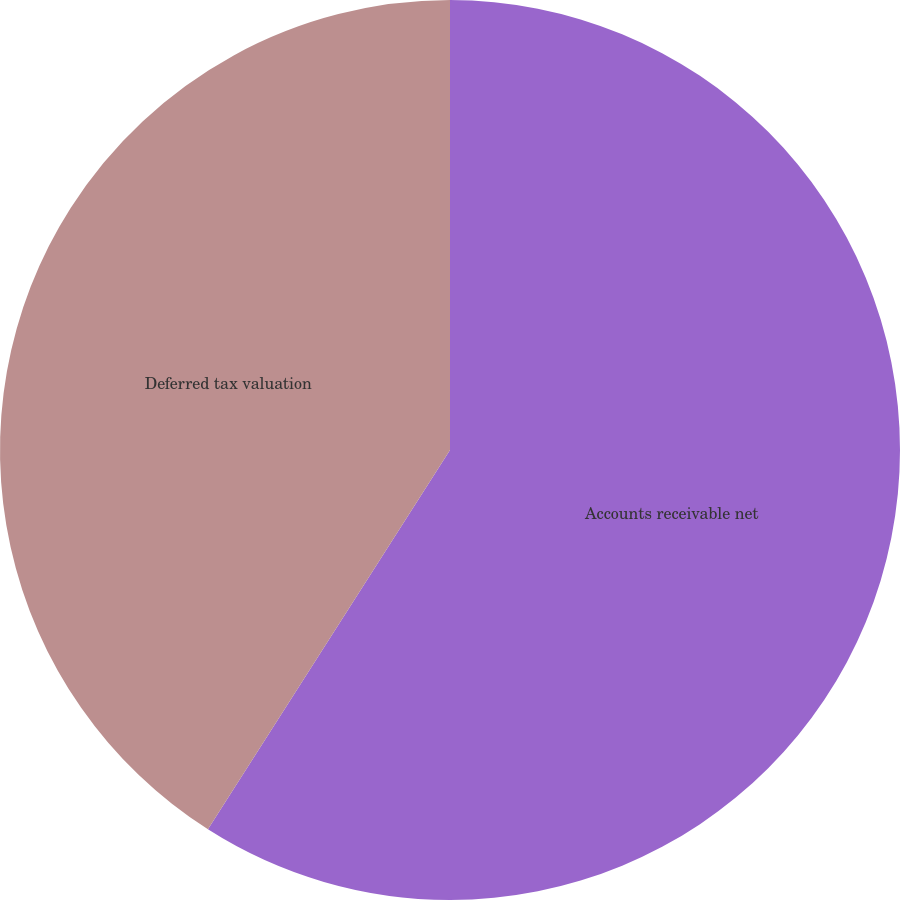Convert chart to OTSL. <chart><loc_0><loc_0><loc_500><loc_500><pie_chart><fcel>Accounts receivable net<fcel>Deferred tax valuation<nl><fcel>59.04%<fcel>40.96%<nl></chart> 